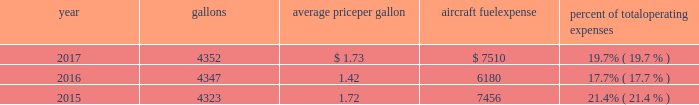( 2 ) our union-represented mainline employees are covered by agreements that are not currently amendable .
Joint collective bargaining agreements ( jcbas ) have been reached with post-merger employee groups , except the maintenance , fleet service , stock clerks , maintenance control technicians and maintenance training instructors represented by the twu-iam association who are covered by separate cbas that become amendable in the third quarter of 2018 .
Until those agreements become amendable , negotiations for jcbas will be conducted outside the traditional rla bargaining process as described above , and , in the meantime , no self-help will be permissible .
( 3 ) among our wholly-owned regional subsidiaries , the psa mechanics and flight attendants have agreements that are now amendable and are engaged in traditional rla negotiations .
The envoy passenger service employees are engaged in traditional rla negotiations for an initial cba .
The piedmont fleet and passenger service employees have reached a tentative five-year agreement which is subject to membership ratification .
For more discussion , see part i , item 1a .
Risk factors 2013 201cunion disputes , employee strikes and other labor-related disruptions may adversely affect our operations . 201d aircraft fuel our operations and financial results are significantly affected by the availability and price of jet fuel , which is our second largest expense .
Based on our 2018 forecasted mainline and regional fuel consumption , we estimate that a one cent per gallon increase in aviation fuel price would increase our 2018 annual fuel expense by $ 45 million .
The table shows annual aircraft fuel consumption and costs , including taxes , for our mainline and regional operations for 2017 , 2016 and 2015 ( gallons and aircraft fuel expense in millions ) .
Year gallons average price per gallon aircraft fuel expense percent of total operating expenses .
As of december 31 , 2017 , we did not have any fuel hedging contracts outstanding to hedge our fuel consumption .
As such , and assuming we do not enter into any future transactions to hedge our fuel consumption , we will continue to be fully exposed to fluctuations in fuel prices .
Our current policy is not to enter into transactions to hedge our fuel consumption , although we review that policy from time to time based on market conditions and other factors .
Fuel prices have fluctuated substantially over the past several years .
We cannot predict the future availability , price volatility or cost of aircraft fuel .
Natural disasters ( including hurricanes or similar events in the u.s .
Southeast and on the gulf coast where a significant portion of domestic refining capacity is located ) , political disruptions or wars involving oil-producing countries , changes in fuel-related governmental policy , the strength of the u.s .
Dollar against foreign currencies , changes in access to petroleum product pipelines and terminals , speculation in the energy futures markets , changes in aircraft fuel production capacity , environmental concerns and other unpredictable events may result in fuel supply shortages , distribution challenges , additional fuel price volatility and cost increases in the future .
See part i , item 1a .
Risk factors 2013 201cour business is very dependent on the price and availability of aircraft fuel .
Continued periods of high volatility in fuel costs , increased fuel prices or significant disruptions in the supply of aircraft fuel could have a significant negative impact on our operating results and liquidity . 201d seasonality and other factors due to the greater demand for air travel during the summer months , revenues in the airline industry in the second and third quarters of the year tend to be greater than revenues in the first and fourth quarters of the year .
General economic conditions , fears of terrorism or war , fare initiatives , fluctuations in fuel prices , labor actions , weather , natural disasters , outbreaks of disease and other factors could impact this seasonal pattern .
Therefore , our quarterly results of operations are not necessarily indicative of operating results for the entire year , and historical operating results in a quarterly or annual period are not necessarily indicative of future operating results. .
Based on the information provided what was the total operating expenses in 2016 in millions? 
Computations: (6180 * 17.7%)
Answer: 1093.86. 